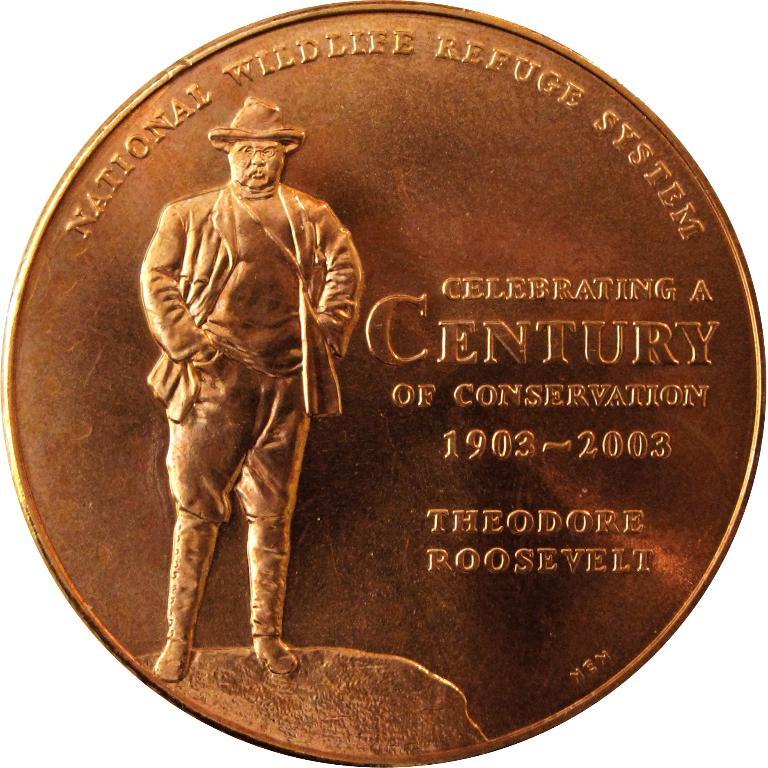What system is celebrating their century of conservation?
Keep it short and to the point. National wildlife refuge system. What is the name listed on this coin?
Your answer should be compact. Theodore roosevelt. 